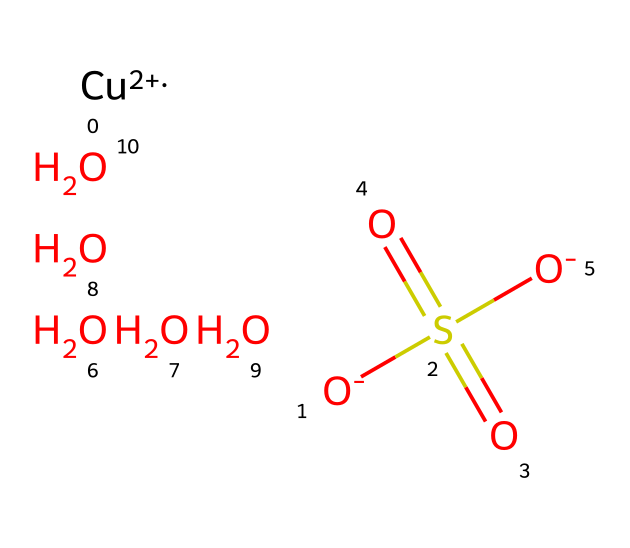What is the central metal in this algaecide? The chemical structure includes a copper ion represented as [Cu+2], indicating copper is the metal present in this algaecide formulation.
Answer: copper How many oxygen atoms are present in the molecule? The SMILES representation shows multiple occurrences of the oxygen symbol, including those in sulfate (S(=O)(=O)[O-]), which contributes three oxygen atoms, plus three additional oxygen atoms, making a total of six.
Answer: six What functional group is indicated by the presence of S(=O)(=O)? The notation indicates a sulfonic acid functional group due to the sulfur atom bonded to oxygen with double bonds to two oxygen atoms and single bonds to two hydroxyl groups.
Answer: sulfonic acid How many geometric isomers can be expected for this compound? Geometric isomers generally arise from restricted rotation around a bond or specific arrangement of atoms. However, this compound does not exhibit such properties, suggesting that it may not have geometric isomers.
Answer: none What is the net charge of the molecule? The molecule has two negatively charged oxygen atoms from the sulfonate and one positively charged copper ion, which balances to make an overall neutral charge. After accounting for all charges, the net charge is neutral.
Answer: neutral What type of isomerism does this compound exhibit? In the given structure, the presence of a central metal ion (copper) and the surrounding ligands imply coordination compounds. However, since the compound has a simple arrangement without complex geometric features or multiple coordination orientations, it doesn't primarily exhibit isomerism.
Answer: none 